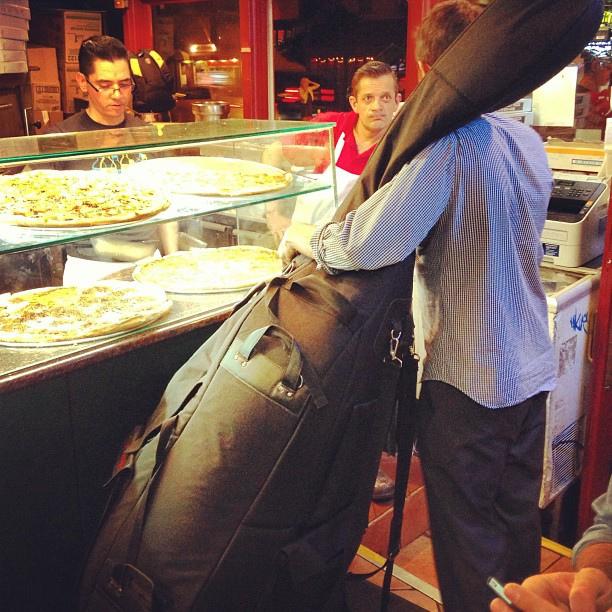Is the man near a food counter?
Answer briefly. Yes. Why is the man carrying so much baggage?
Give a very brief answer. Travel. Is the woman taking a picture of the plate in the man's hand?
Write a very short answer. No. How many trays of food are under the heat lamp?
Keep it brief. 4. Where are the food?
Answer briefly. Pizza. Is the person in the picture wearing a solid or floral-print top?
Keep it brief. Solid. Are there any women in this picture?
Answer briefly. No. Are the pizzas in the window cooked yet?
Concise answer only. Yes. Are the workers wearing visors?
Write a very short answer. No. Are there sandwiches in the display cases?
Give a very brief answer. No. 